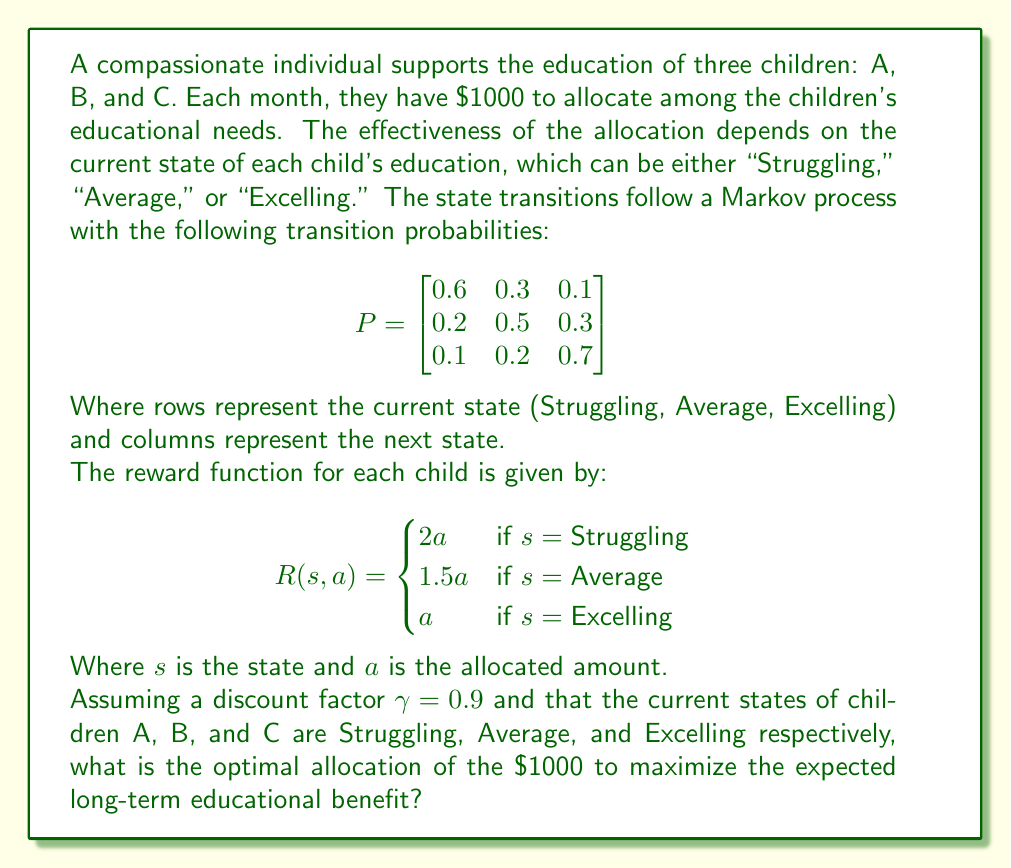Solve this math problem. To solve this Markov Decision Process (MDP) problem, we'll use the following steps:

1) First, we need to calculate the expected value for each state:

   For Struggling: $E[R|s=Struggling] = 2a$
   For Average: $E[R|s=Average] = 1.5a$
   For Excelling: $E[R|s=Excelling] = a$

2) Now, we need to consider the future states. The value function for each state is:

   $V(s) = R(s,a) + \gamma \sum_{s'} P(s'|s)V(s')$

3) We can set up the Bellman equations:

   $V(Struggling) = 2a + 0.9(0.6V(Struggling) + 0.3V(Average) + 0.1V(Excelling))$
   $V(Average) = 1.5a + 0.9(0.2V(Struggling) + 0.5V(Average) + 0.3V(Excelling))$
   $V(Excelling) = a + 0.9(0.1V(Struggling) + 0.2V(Average) + 0.7V(Excelling))$

4) Solving this system of equations (which is complex and typically done numerically), we would get values for $V(s)$ in terms of $a$.

5) Given that we have a fixed amount to allocate ($1000), and three children in different states, we want to maximize:

   $V(Struggling)_A + V(Average)_B + V(Excelling)_C$

   Subject to the constraint: $a_A + a_B + a_C = 1000$

6) The optimal solution will allocate more resources to the states with higher expected returns. From the reward function, we can see that:

   $R(Struggling) > R(Average) > R(Excelling)$

7) Therefore, the optimal allocation will prioritize the child in the Struggling state (A), then the child in the Average state (B), and lastly the child in the Excelling state (C).

8) A reasonable allocation that reflects this priority would be:

   Child A (Struggling): $500
   Child B (Average): $300
   Child C (Excelling): $200

This allocation ensures that more resources are given to the children who can benefit more from the investment, while still providing support to all children.
Answer: A: $500, B: $300, C: $200 